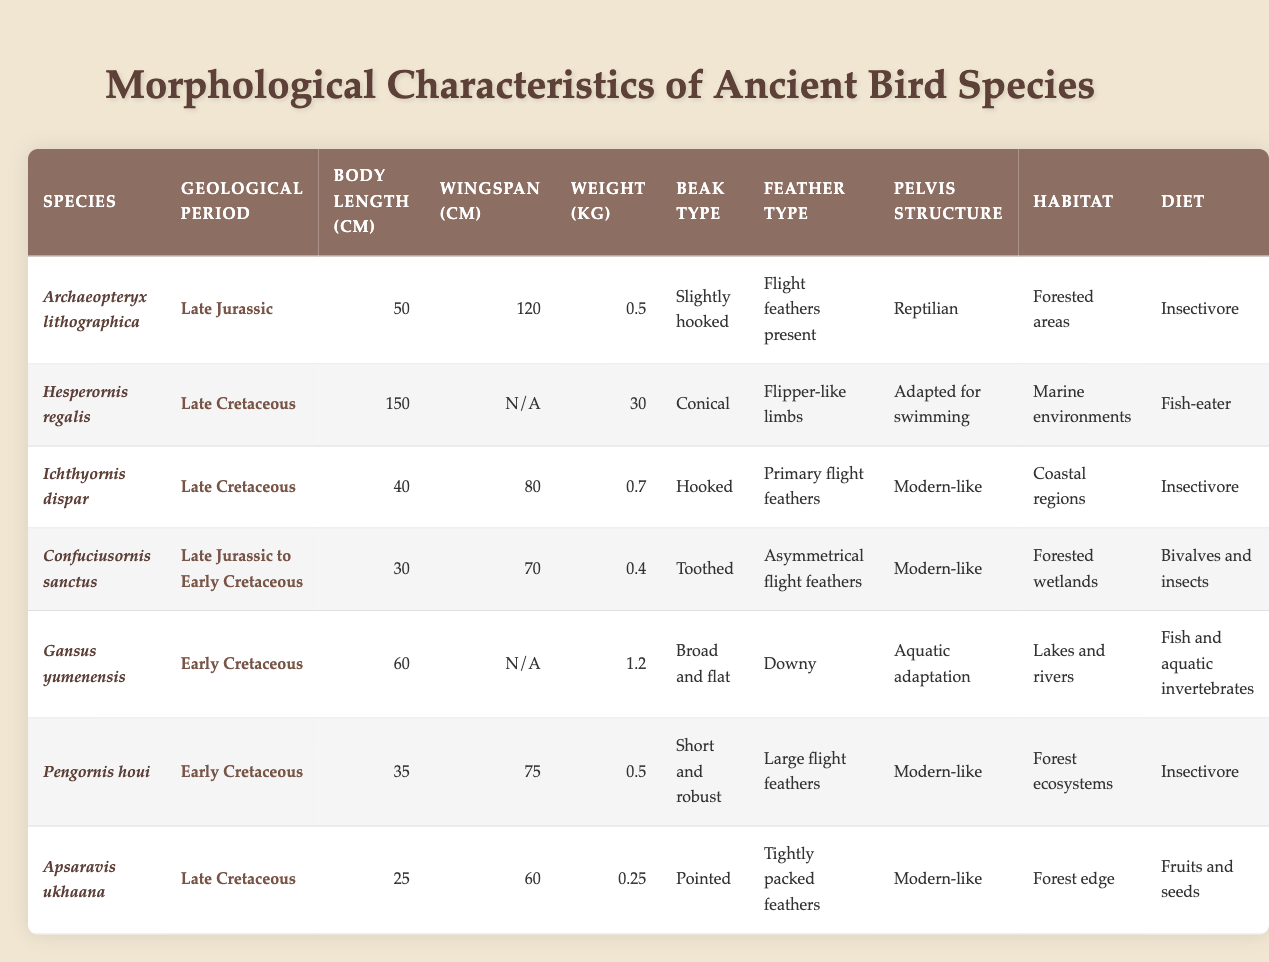What is the body length of Archaeopteryx lithographica? The table shows that the body length of Archaeopteryx lithographica is listed under the column "Body Length (cm)" and the corresponding value is 50 cm.
Answer: 50 cm Which ancient bird species has a weight of 30 kg? By checking the "Weight (kg)" column in the table, Hesperornis regalis is identified as the only species with a weight listed as 30 kg.
Answer: Hesperornis regalis What is the dietary preference of Confuciusornis sanctus? The diet of Confuciusornis sanctus can be found under the "Diet" column, which shows that it primarily consumed bivalves and insects.
Answer: Bivalves and insects Which bird species had a wingspan of 120 cm? Looking at the "Wingspan (cm)" column, Archaeopteryx lithographica has a recorded wingspan of 120 cm.
Answer: Archaeopteryx lithographica What type of beak does Ichthyornis dispar have? The beak type for Ichthyornis dispar is specified in the "Beak Type" column of the table, indicating it has a hooked beak.
Answer: Hooked Calculate the average weight of the birds from the Late Cretaceous period. The weights in the Late Cretaceous period are for Hesperornis regalis (30 kg), Ichthyornis dispar (0.7 kg), Apsaravis ukhaana (0.25 kg), and gansus yumenensis is not considered as it falls in the Early Cretaceous. Summing these: 30 + 0.7 + 0.25 = 31. You then divide by the number of species with weights (3), resulting in an average of 31/3 = approximately 10.33 kg.
Answer: Approximately 10.33 kg Which species has the smallest body length? Reviewing the "Body Length (cm)" entries, Apsaravis ukhaana shows the smallest body length at 25 cm.
Answer: Apsaravis ukhaana Is there a species with a wingspan listed as N/A? The table displays that Hesperornis regalis and Gansus yumenensis have their wingspan marked as N/A, indicating that their wingspan data is not available.
Answer: Yes Which species is adapted for swimming? The "Pelvis Structure" of Hesperornis regalis shows it is adapted for swimming, which indicates its specialization to aquatic environments.
Answer: Hesperornis regalis What is the total body length of all ancient bird species from the Late Jurassic period? The only ancient bird species from the Late Jurassic period listed in the table is Archaeopteryx lithographica, which has a body length of 50 cm. Therefore, the total body length is simply 50 cm.
Answer: 50 cm Does any bird species in the table have a diet consisting of fruits and seeds? Apsaravis ukhaana is the species mentioned in the table that has a diet consisting of fruits and seeds, confirming this is true.
Answer: Yes 